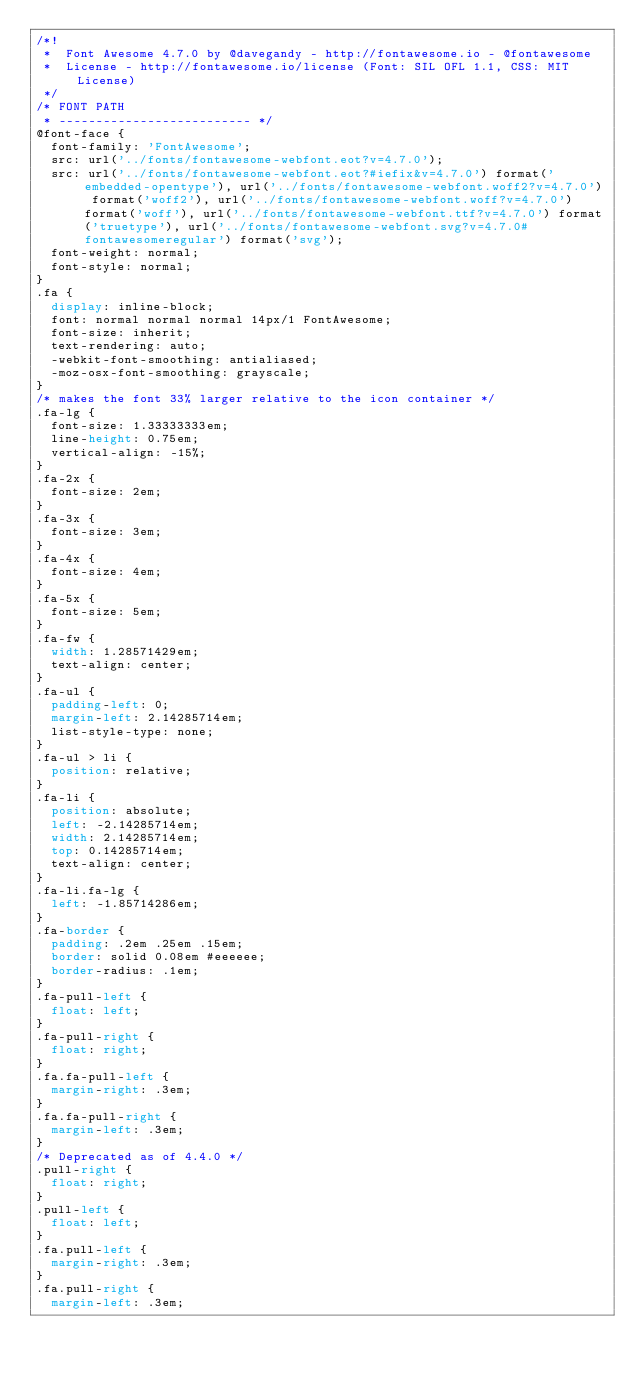<code> <loc_0><loc_0><loc_500><loc_500><_CSS_>/*!
 *  Font Awesome 4.7.0 by @davegandy - http://fontawesome.io - @fontawesome
 *  License - http://fontawesome.io/license (Font: SIL OFL 1.1, CSS: MIT License)
 */
/* FONT PATH
 * -------------------------- */
@font-face {
  font-family: 'FontAwesome';
  src: url('../fonts/fontawesome-webfont.eot?v=4.7.0');
  src: url('../fonts/fontawesome-webfont.eot?#iefix&v=4.7.0') format('embedded-opentype'), url('../fonts/fontawesome-webfont.woff2?v=4.7.0') format('woff2'), url('../fonts/fontawesome-webfont.woff?v=4.7.0') format('woff'), url('../fonts/fontawesome-webfont.ttf?v=4.7.0') format('truetype'), url('../fonts/fontawesome-webfont.svg?v=4.7.0#fontawesomeregular') format('svg');
  font-weight: normal;
  font-style: normal;
}
.fa {
  display: inline-block;
  font: normal normal normal 14px/1 FontAwesome;
  font-size: inherit;
  text-rendering: auto;
  -webkit-font-smoothing: antialiased;
  -moz-osx-font-smoothing: grayscale;
}
/* makes the font 33% larger relative to the icon container */
.fa-lg {
  font-size: 1.33333333em;
  line-height: 0.75em;
  vertical-align: -15%;
}
.fa-2x {
  font-size: 2em;
}
.fa-3x {
  font-size: 3em;
}
.fa-4x {
  font-size: 4em;
}
.fa-5x {
  font-size: 5em;
}
.fa-fw {
  width: 1.28571429em;
  text-align: center;
}
.fa-ul {
  padding-left: 0;
  margin-left: 2.14285714em;
  list-style-type: none;
}
.fa-ul > li {
  position: relative;
}
.fa-li {
  position: absolute;
  left: -2.14285714em;
  width: 2.14285714em;
  top: 0.14285714em;
  text-align: center;
}
.fa-li.fa-lg {
  left: -1.85714286em;
}
.fa-border {
  padding: .2em .25em .15em;
  border: solid 0.08em #eeeeee;
  border-radius: .1em;
}
.fa-pull-left {
  float: left;
}
.fa-pull-right {
  float: right;
}
.fa.fa-pull-left {
  margin-right: .3em;
}
.fa.fa-pull-right {
  margin-left: .3em;
}
/* Deprecated as of 4.4.0 */
.pull-right {
  float: right;
}
.pull-left {
  float: left;
}
.fa.pull-left {
  margin-right: .3em;
}
.fa.pull-right {
  margin-left: .3em;</code> 